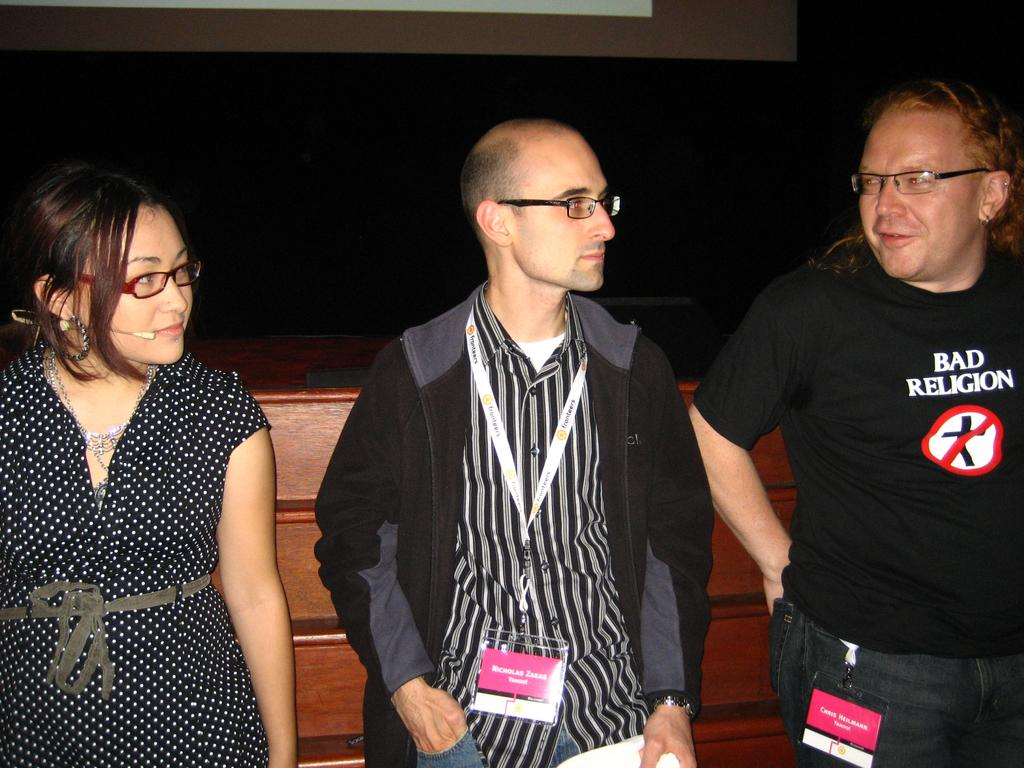How many people are present in the image? There are people standing in the image. Can you describe what one of the people is doing? One of the people is attached to a mic. What type of scissors can be seen being used by the horse in the image? There is no horse or scissors present in the image. 